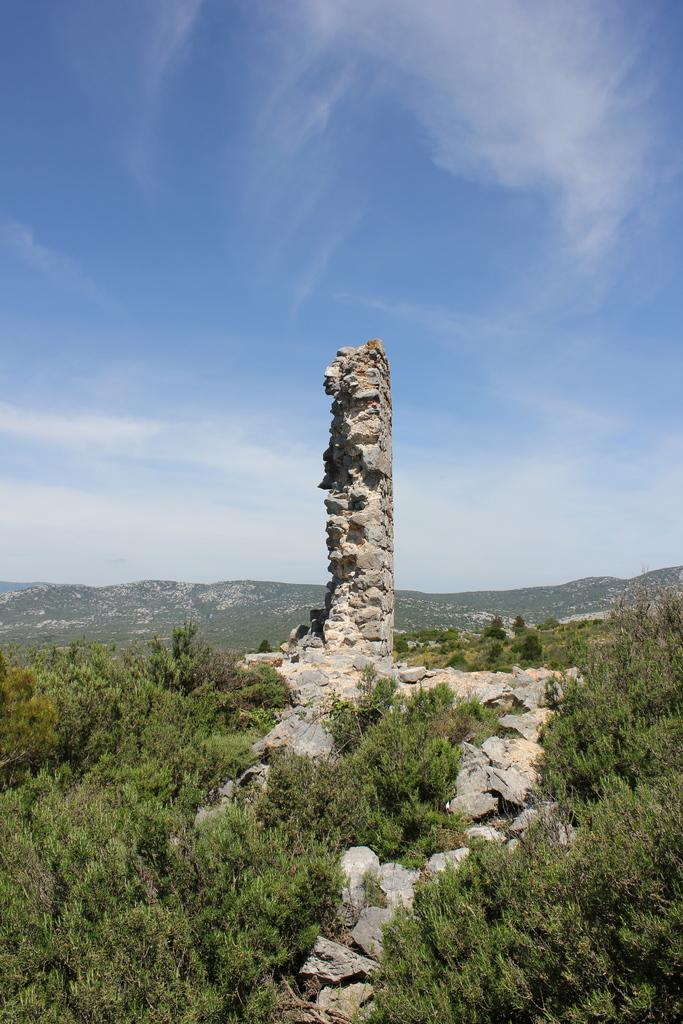What type of natural elements can be seen in the image? There are rocks, trees, and hills visible in the image. What is visible in the background of the image? The sky is visible in the image, with clouds present. Can you describe the terrain in the image? The terrain in the image includes hills and rocks. What type of camera is being used to take the picture of the pipe in the class? There is no camera, pipe, or class present in the image; it features rocks, trees, hills, sky, and clouds. 